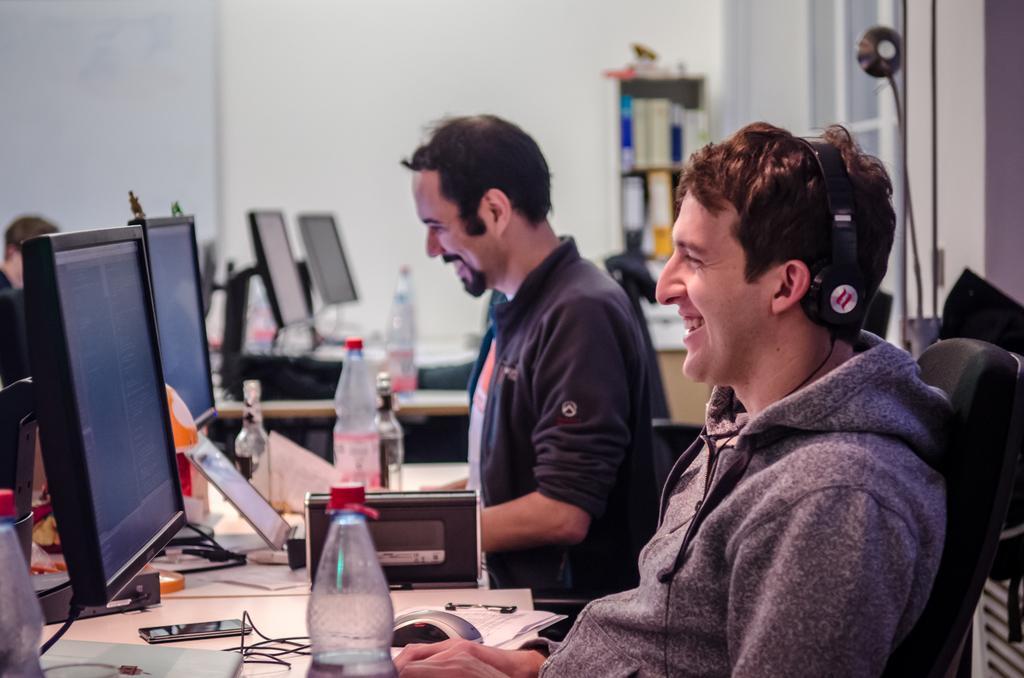In one or two sentences, can you explain what this image depicts? In the bottom left corner of the image we can see a table, on the table there are some bottles, mobile phones, wires, screens, papers and pens. In the bottom right corner of the image two persons are sitting and smiling. At the top of the image there is wall. 